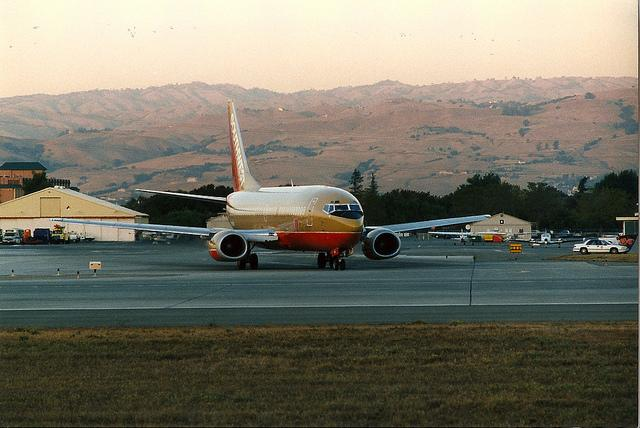What is the plane doing that requires it to be perpendicular to the runway? taxiing 